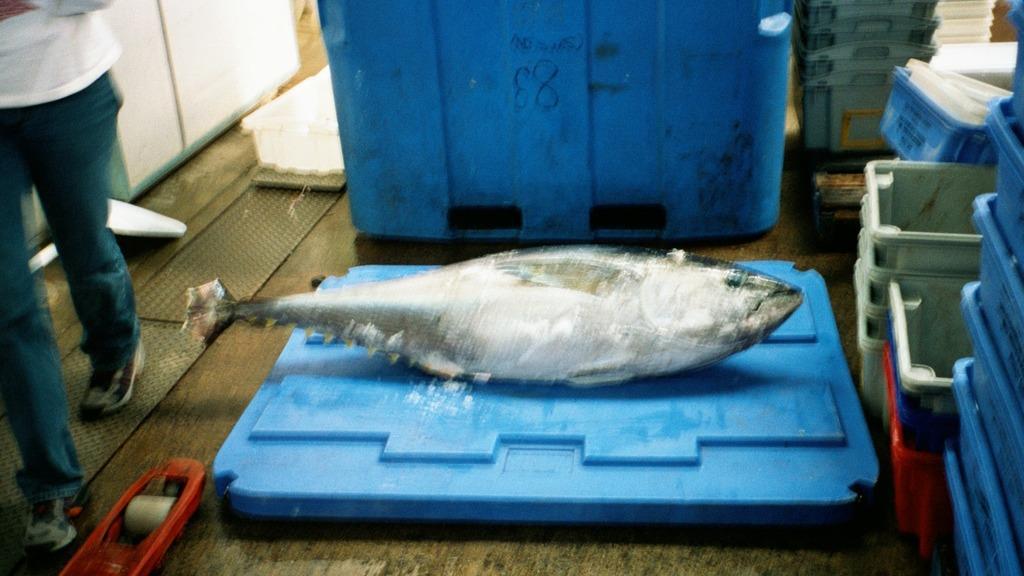Describe this image in one or two sentences. In this picture we can see a fish in the front, on the left side there is a person walking, on the right side there are some trays. 